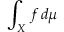Convert formula to latex. <formula><loc_0><loc_0><loc_500><loc_500>\int _ { X } f \, d \mu</formula> 